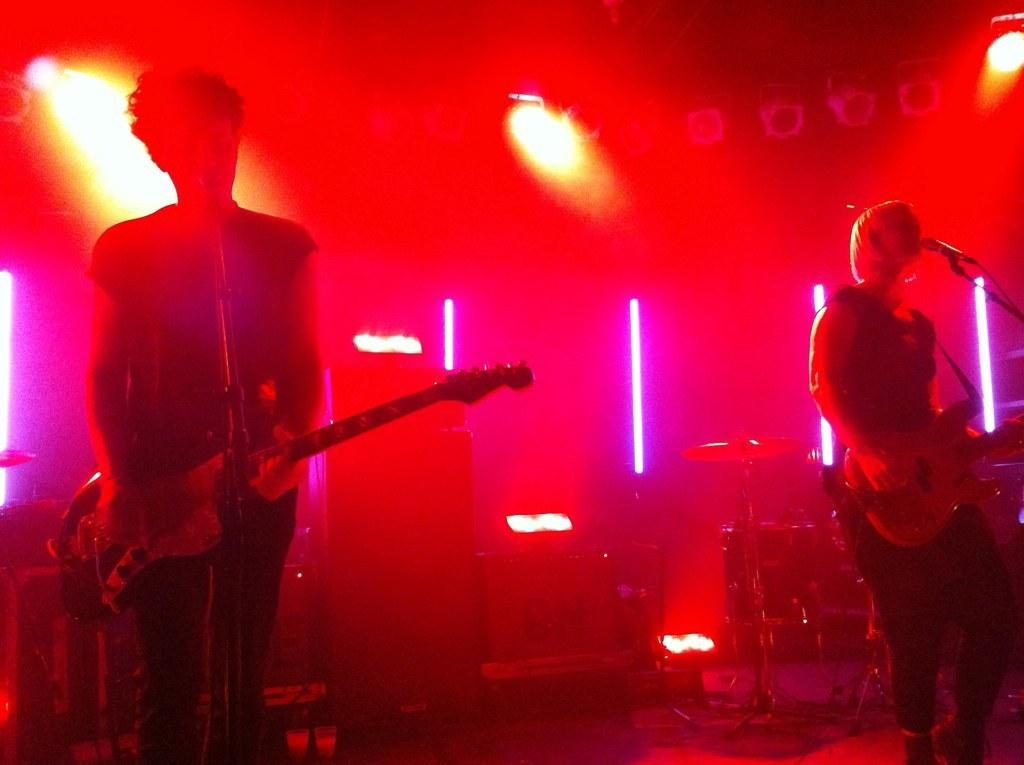How many people are in the image? There are two persons in the image. What are the two persons doing in the image? The two persons are standing in front of a microphone and playing guitar. What can be seen in the background of the image? There are lights visible in the background of the image. Can you tell me how many tickets the stranger is holding in the image? There is no stranger present in the image, and therefore no tickets can be observed. What type of dirt is visible on the guitar in the image? There is no dirt visible on the guitar in the image. 